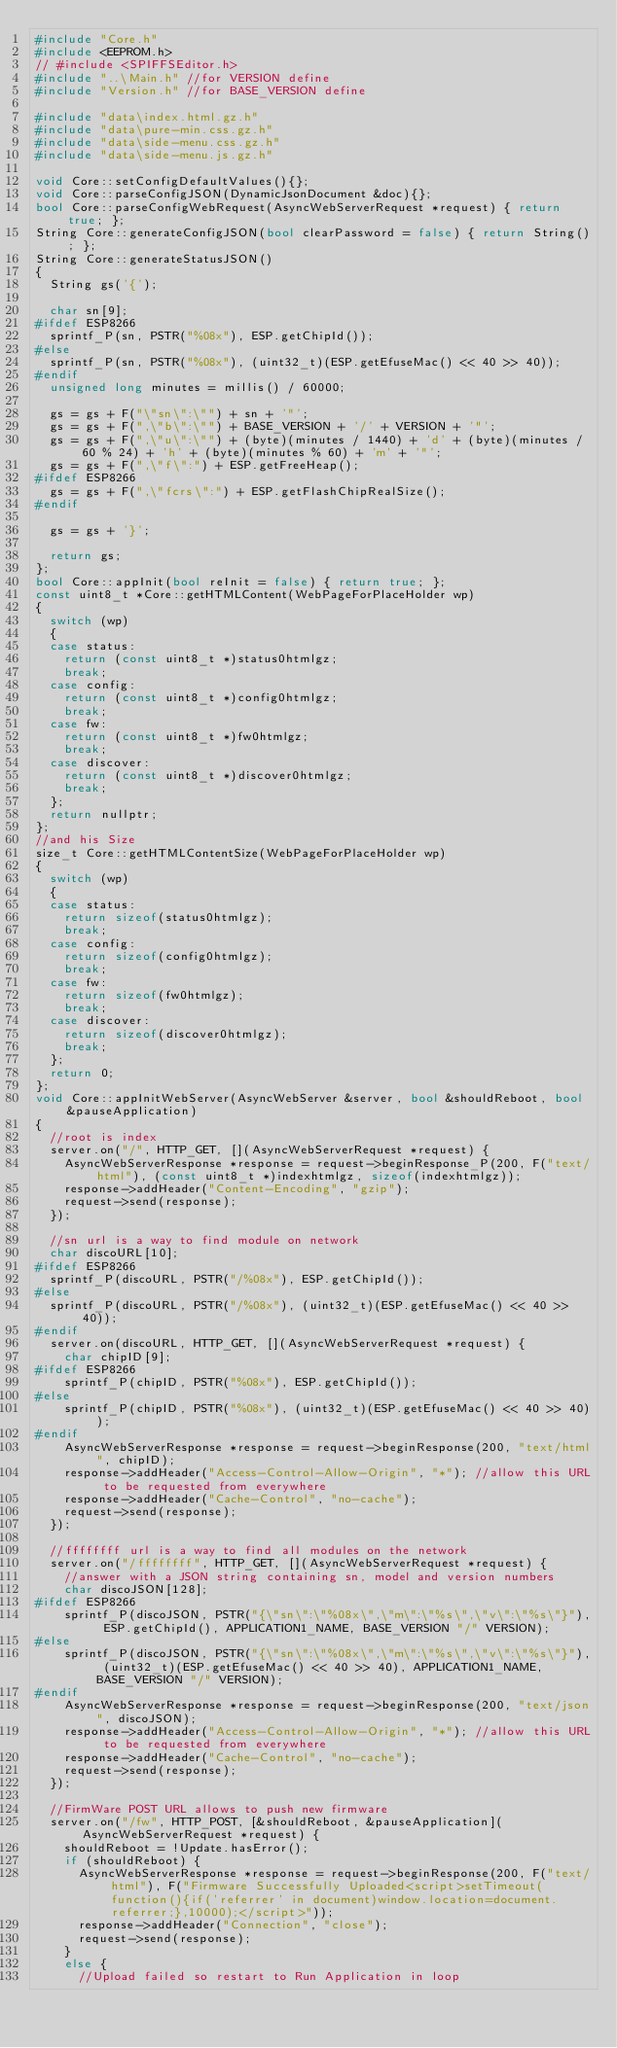Convert code to text. <code><loc_0><loc_0><loc_500><loc_500><_C++_>#include "Core.h"
#include <EEPROM.h>
// #include <SPIFFSEditor.h>
#include "..\Main.h" //for VERSION define
#include "Version.h" //for BASE_VERSION define

#include "data\index.html.gz.h"
#include "data\pure-min.css.gz.h"
#include "data\side-menu.css.gz.h"
#include "data\side-menu.js.gz.h"

void Core::setConfigDefaultValues(){};
void Core::parseConfigJSON(DynamicJsonDocument &doc){};
bool Core::parseConfigWebRequest(AsyncWebServerRequest *request) { return true; };
String Core::generateConfigJSON(bool clearPassword = false) { return String(); };
String Core::generateStatusJSON()
{
  String gs('{');

  char sn[9];
#ifdef ESP8266
  sprintf_P(sn, PSTR("%08x"), ESP.getChipId());
#else
  sprintf_P(sn, PSTR("%08x"), (uint32_t)(ESP.getEfuseMac() << 40 >> 40));
#endif
  unsigned long minutes = millis() / 60000;

  gs = gs + F("\"sn\":\"") + sn + '"';
  gs = gs + F(",\"b\":\"") + BASE_VERSION + '/' + VERSION + '"';
  gs = gs + F(",\"u\":\"") + (byte)(minutes / 1440) + 'd' + (byte)(minutes / 60 % 24) + 'h' + (byte)(minutes % 60) + 'm' + '"';
  gs = gs + F(",\"f\":") + ESP.getFreeHeap();
#ifdef ESP8266
  gs = gs + F(",\"fcrs\":") + ESP.getFlashChipRealSize();
#endif

  gs = gs + '}';

  return gs;
};
bool Core::appInit(bool reInit = false) { return true; };
const uint8_t *Core::getHTMLContent(WebPageForPlaceHolder wp)
{
  switch (wp)
  {
  case status:
    return (const uint8_t *)status0htmlgz;
    break;
  case config:
    return (const uint8_t *)config0htmlgz;
    break;
  case fw:
    return (const uint8_t *)fw0htmlgz;
    break;
  case discover:
    return (const uint8_t *)discover0htmlgz;
    break;
  };
  return nullptr;
};
//and his Size
size_t Core::getHTMLContentSize(WebPageForPlaceHolder wp)
{
  switch (wp)
  {
  case status:
    return sizeof(status0htmlgz);
    break;
  case config:
    return sizeof(config0htmlgz);
    break;
  case fw:
    return sizeof(fw0htmlgz);
    break;
  case discover:
    return sizeof(discover0htmlgz);
    break;
  };
  return 0;
};
void Core::appInitWebServer(AsyncWebServer &server, bool &shouldReboot, bool &pauseApplication)
{
  //root is index
  server.on("/", HTTP_GET, [](AsyncWebServerRequest *request) {
    AsyncWebServerResponse *response = request->beginResponse_P(200, F("text/html"), (const uint8_t *)indexhtmlgz, sizeof(indexhtmlgz));
    response->addHeader("Content-Encoding", "gzip");
    request->send(response);
  });

  //sn url is a way to find module on network
  char discoURL[10];
#ifdef ESP8266
  sprintf_P(discoURL, PSTR("/%08x"), ESP.getChipId());
#else
  sprintf_P(discoURL, PSTR("/%08x"), (uint32_t)(ESP.getEfuseMac() << 40 >> 40));
#endif
  server.on(discoURL, HTTP_GET, [](AsyncWebServerRequest *request) {
    char chipID[9];
#ifdef ESP8266
    sprintf_P(chipID, PSTR("%08x"), ESP.getChipId());
#else
    sprintf_P(chipID, PSTR("%08x"), (uint32_t)(ESP.getEfuseMac() << 40 >> 40));
#endif
    AsyncWebServerResponse *response = request->beginResponse(200, "text/html", chipID);
    response->addHeader("Access-Control-Allow-Origin", "*"); //allow this URL to be requested from everywhere
    response->addHeader("Cache-Control", "no-cache");
    request->send(response);
  });

  //ffffffff url is a way to find all modules on the network
  server.on("/ffffffff", HTTP_GET, [](AsyncWebServerRequest *request) {
    //answer with a JSON string containing sn, model and version numbers
    char discoJSON[128];
#ifdef ESP8266
    sprintf_P(discoJSON, PSTR("{\"sn\":\"%08x\",\"m\":\"%s\",\"v\":\"%s\"}"), ESP.getChipId(), APPLICATION1_NAME, BASE_VERSION "/" VERSION);
#else
    sprintf_P(discoJSON, PSTR("{\"sn\":\"%08x\",\"m\":\"%s\",\"v\":\"%s\"}"), (uint32_t)(ESP.getEfuseMac() << 40 >> 40), APPLICATION1_NAME, BASE_VERSION "/" VERSION);
#endif
    AsyncWebServerResponse *response = request->beginResponse(200, "text/json", discoJSON);
    response->addHeader("Access-Control-Allow-Origin", "*"); //allow this URL to be requested from everywhere
    response->addHeader("Cache-Control", "no-cache");
    request->send(response);
  });

  //FirmWare POST URL allows to push new firmware
  server.on("/fw", HTTP_POST, [&shouldReboot, &pauseApplication](AsyncWebServerRequest *request) {
    shouldReboot = !Update.hasError();
    if (shouldReboot) {
      AsyncWebServerResponse *response = request->beginResponse(200, F("text/html"), F("Firmware Successfully Uploaded<script>setTimeout(function(){if('referrer' in document)window.location=document.referrer;},10000);</script>"));
      response->addHeader("Connection", "close");
      request->send(response);
    }
    else {
      //Upload failed so restart to Run Application in loop</code> 